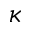Convert formula to latex. <formula><loc_0><loc_0><loc_500><loc_500>\kappa</formula> 